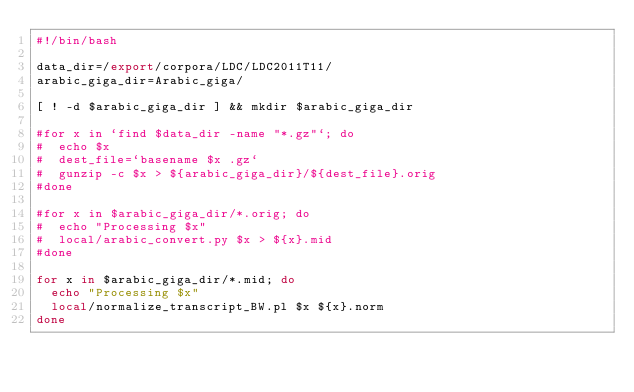<code> <loc_0><loc_0><loc_500><loc_500><_Bash_>#!/bin/bash

data_dir=/export/corpora/LDC/LDC2011T11/
arabic_giga_dir=Arabic_giga/

[ ! -d $arabic_giga_dir ] && mkdir $arabic_giga_dir

#for x in `find $data_dir -name "*.gz"`; do
#  echo $x
#  dest_file=`basename $x .gz`
#  gunzip -c $x > ${arabic_giga_dir}/${dest_file}.orig
#done

#for x in $arabic_giga_dir/*.orig; do
#  echo "Processing $x"
#  local/arabic_convert.py $x > ${x}.mid
#done

for x in $arabic_giga_dir/*.mid; do
  echo "Processing $x"
  local/normalize_transcript_BW.pl $x ${x}.norm
done
</code> 